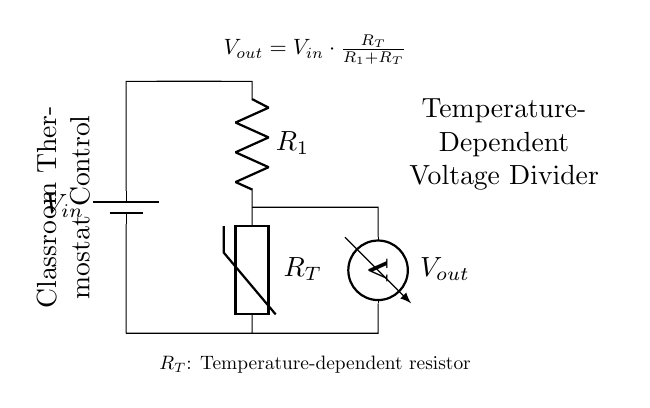What type of circuit is shown? The circuit is a voltage divider, which is used to divide input voltage among its components.
Answer: Voltage divider What does V_out represent in the circuit? V_out is the output voltage across the thermistor and is defined by the voltage drop across it.
Answer: Output voltage What is R_T in the diagram? R_T denotes the thermistor, which is a temperature-dependent resistor. Its resistance changes with temperature.
Answer: Thermistor How is V_out calculated? V_out is calculated using the formula V_out = V_in * (R_T / (R_1 + R_T)), which describes the relationship between input voltage, the thermistor, and the resistor.
Answer: V_in * (R_T / (R_1 + R_T)) If R_1 is 2k ohm and R_T is 3k ohm, what is V_out if V_in is 10V? First, we substitute the values into the formula: V_out = 10 * (3 / (2 + 3)) = 10 * (3 / 5) = 6V.
Answer: 6V What happens to V_out if temperature increases (R_T decreases)? As the temperature increases, R_T usually decreases, which leads to a decrease in V_out according to the voltage divider effect.
Answer: Decrease in V_out 